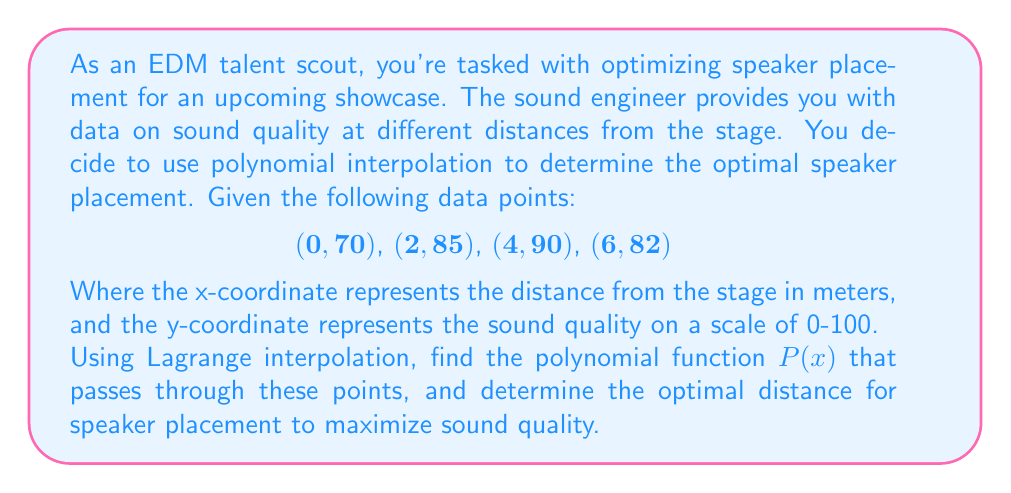Can you answer this question? To solve this problem, we'll use Lagrange interpolation to find the polynomial function $P(x)$ and then determine its maximum value.

1. Lagrange interpolation formula:
   $$P(x) = \sum_{i=0}^{n} y_i \cdot L_i(x)$$
   where $L_i(x) = \prod_{j \neq i} \frac{x - x_j}{x_i - x_j}$

2. Calculate $L_i(x)$ for each point:

   $$L_0(x) = \frac{(x-2)(x-4)(x-6)}{(0-2)(0-4)(0-6)} = \frac{x^3 - 12x^2 + 44x - 48}{48}$$
   
   $$L_1(x) = \frac{(x-0)(x-4)(x-6)}{(2-0)(2-4)(2-6)} = -\frac{x^3 - 10x^2 + 24x}{16}$$
   
   $$L_2(x) = \frac{(x-0)(x-2)(x-6)}{(4-0)(4-2)(4-6)} = \frac{x^3 - 8x^2 + 12x}{16}$$
   
   $$L_3(x) = \frac{(x-0)(x-2)(x-4)}{(6-0)(6-2)(6-4)} = -\frac{x^3 - 6x^2 + 8x}{48}$$

3. Construct $P(x)$:

   $$P(x) = 70 \cdot L_0(x) + 85 \cdot L_1(x) + 90 \cdot L_2(x) + 82 \cdot L_3(x)$$

4. Simplify $P(x)$:

   $$P(x) = -\frac{5}{48}x^3 + \frac{5}{8}x^2 + \frac{55}{24}x + 70$$

5. To find the maximum, differentiate $P(x)$ and set it to zero:

   $$P'(x) = -\frac{15}{48}x^2 + \frac{5}{4}x + \frac{55}{24} = 0$$

6. Solve the quadratic equation:

   $$-\frac{15}{48}x^2 + \frac{5}{4}x + \frac{55}{24} = 0$$
   $$-5x^2 + 20x + 55 = 0$$
   $$x = \frac{-20 \pm \sqrt{400 + 1100}}{-10} = \frac{-20 \pm \sqrt{1500}}{-10}$$

7. The positive solution is the maximum:

   $$x = \frac{-20 + \sqrt{1500}}{-10} \approx 3.87$$

Therefore, the optimal distance for speaker placement is approximately 3.87 meters from the stage.
Answer: The optimal distance for speaker placement is approximately 3.87 meters from the stage, where the sound quality is maximized according to the interpolated polynomial function. 